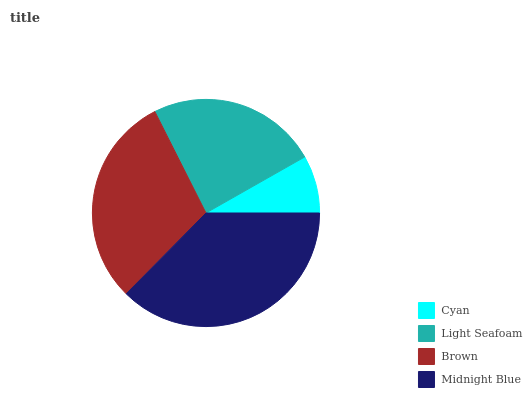Is Cyan the minimum?
Answer yes or no. Yes. Is Midnight Blue the maximum?
Answer yes or no. Yes. Is Light Seafoam the minimum?
Answer yes or no. No. Is Light Seafoam the maximum?
Answer yes or no. No. Is Light Seafoam greater than Cyan?
Answer yes or no. Yes. Is Cyan less than Light Seafoam?
Answer yes or no. Yes. Is Cyan greater than Light Seafoam?
Answer yes or no. No. Is Light Seafoam less than Cyan?
Answer yes or no. No. Is Brown the high median?
Answer yes or no. Yes. Is Light Seafoam the low median?
Answer yes or no. Yes. Is Light Seafoam the high median?
Answer yes or no. No. Is Brown the low median?
Answer yes or no. No. 